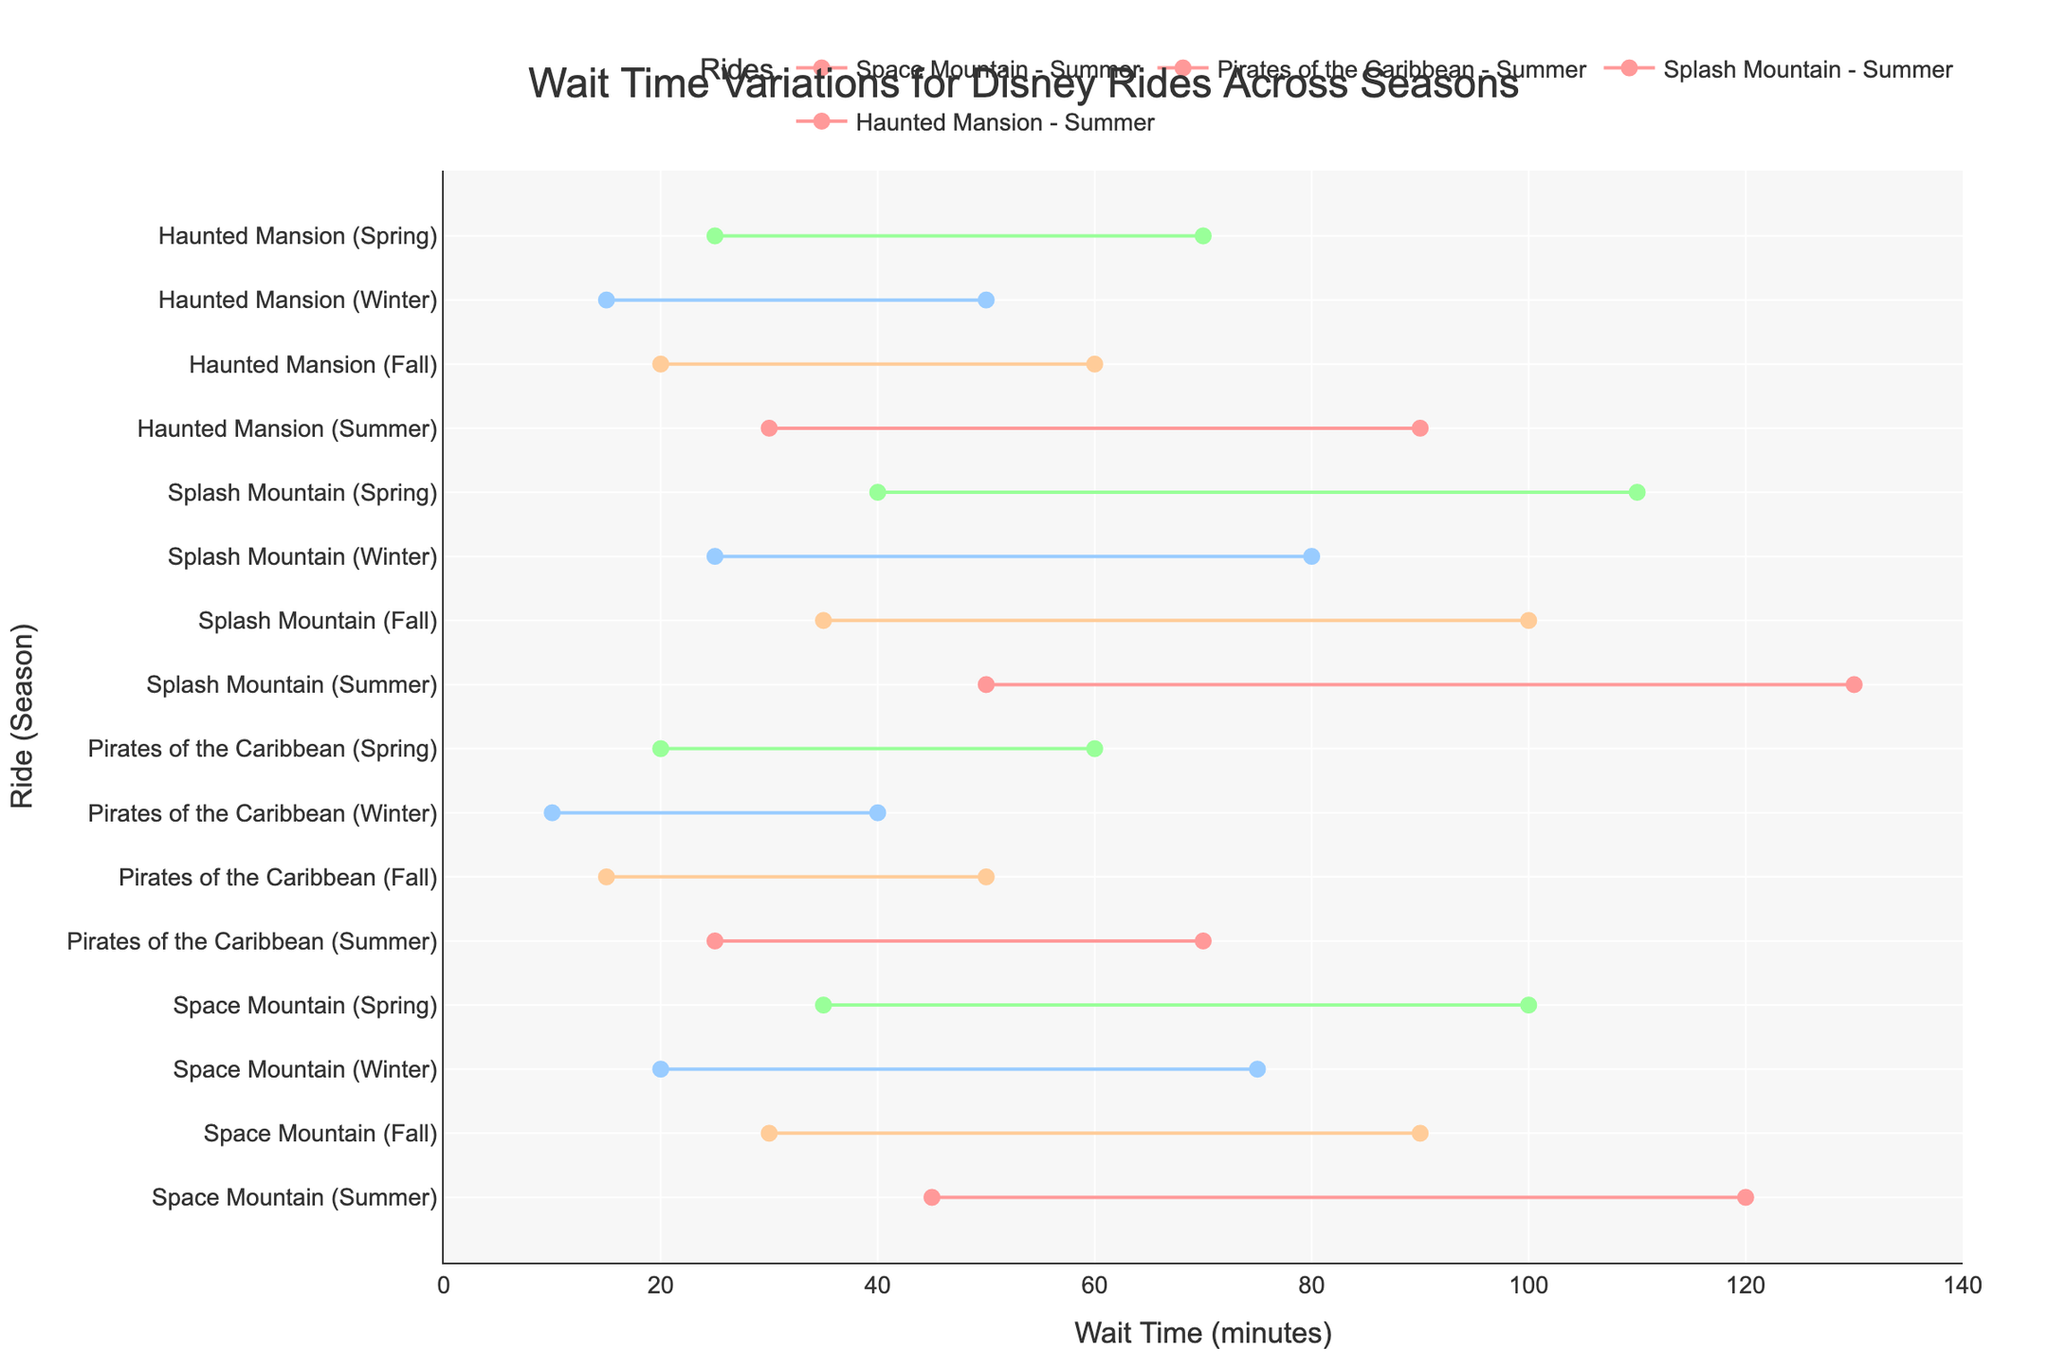What's the average minimum wait time for Space Mountain across all seasons? The minimum wait times for Space Mountain across all seasons are 45, 30, 20, and 35 minutes. Summing these values gives 130, and the average is 130 / 4.
Answer: 32.5 minutes Which ride has the highest max wait time in Winter? From the data, the max wait times in Winter are: Space Mountain (75), Pirates of the Caribbean (40), Splash Mountain (80), and Haunted Mansion (50). The highest is Splash Mountain.
Answer: Splash Mountain What's the difference in max wait times between Summer and Winter for Splash Mountain? For Splash Mountain, the max wait times are 130 minutes in Summer and 80 minutes in Winter. The difference is 130 - 80.
Answer: 50 minutes In which season does Pirates of the Caribbean have the lowest minimum wait time? Looking at the minimum wait times for Pirates of the Caribbean, we have: Summer (25), Fall (15), Winter (10), Spring (20). The lowest is in Winter.
Answer: Winter How does the max wait time for Space Mountain in Fall compare with the max wait time for Splash Mountain in Spring? The max wait time for Space Mountain in Fall is 90 minutes, while for Splash Mountain in Spring it is 110 minutes. 90 < 110, so it is less.
Answer: Less Is the range of wait times for Haunted Mansion in Spring wider or narrower compared to Fall? The range is calculated as max wait time minus min wait time. For Spring, Haunted Mansion's range is 70 - 25 = 45 minutes. For Fall, it's 60 - 20 = 40 minutes. 45 > 40, so Spring has a wider range.
Answer: Wider What's the median max wait time for all rides during Summer? The max wait times for all rides in Summer are: 120, 70, 130, and 90. Arranged in ascending order: 70, 90, 120, 130. The median value is the average of the two middle numbers: (90 + 120) / 2.
Answer: 105 minutes Which ride shows the smallest change in minimum wait time between Summer and Winter? Calculating the changes: 
- Space Mountain: 45 - 20 = 25
- Pirates of the Caribbean: 25 - 10 = 15
- Splash Mountain: 50 - 25 = 25
- Haunted Mansion: 30 - 15 = 15
Pirates of the Caribbean and Haunted Mansion both have the smallest change.
Answer: Pirates of the Caribbean and Haunted Mansion What's the average max wait time for Haunted Mansion across all seasons? The max wait times for Haunted Mansion are: 90, 60, 50, and 70. Summing these: 90 + 60 + 50 + 70 = 270. The average is 270 / 4.
Answer: 67.5 minutes Which season generally has the highest max wait times for the rides? Reviewing max wait times for each season:
- Summer: Space Mountain (120), Pirates of the Caribbean (70), Splash Mountain (130), Haunted Mansion (90)
- Fall: Space Mountain (90), Pirates of the Caribbean (50), Splash Mountain (100), Haunted Mansion (60)
- Winter: Space Mountain (75), Pirates of the Caribbean (40), Splash Mountain (80), Haunted Mansion (50)
- Spring: Space Mountain (100), Pirates of the Caribbean (60), Splash Mountain (110), Haunted Mansion (70)
Summer has the highest max wait times (120, 70, 130, 90).
Answer: Summer 